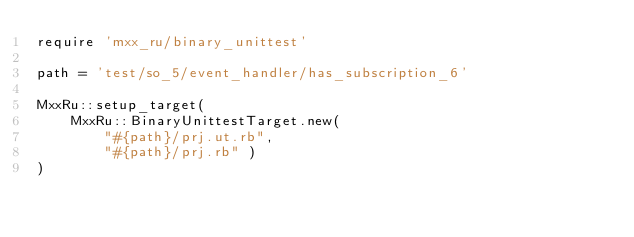<code> <loc_0><loc_0><loc_500><loc_500><_Ruby_>require 'mxx_ru/binary_unittest'

path = 'test/so_5/event_handler/has_subscription_6'

MxxRu::setup_target(
	MxxRu::BinaryUnittestTarget.new(
		"#{path}/prj.ut.rb",
		"#{path}/prj.rb" )
)
</code> 